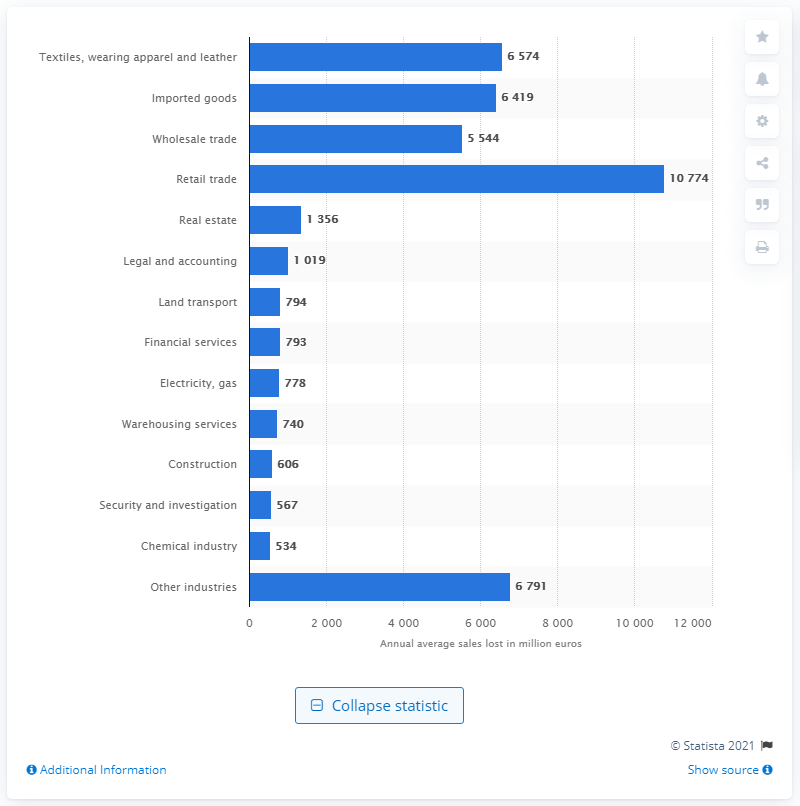Highlight a few significant elements in this photo. The average amount of lost sales per year for retail and trade is 10,774. 